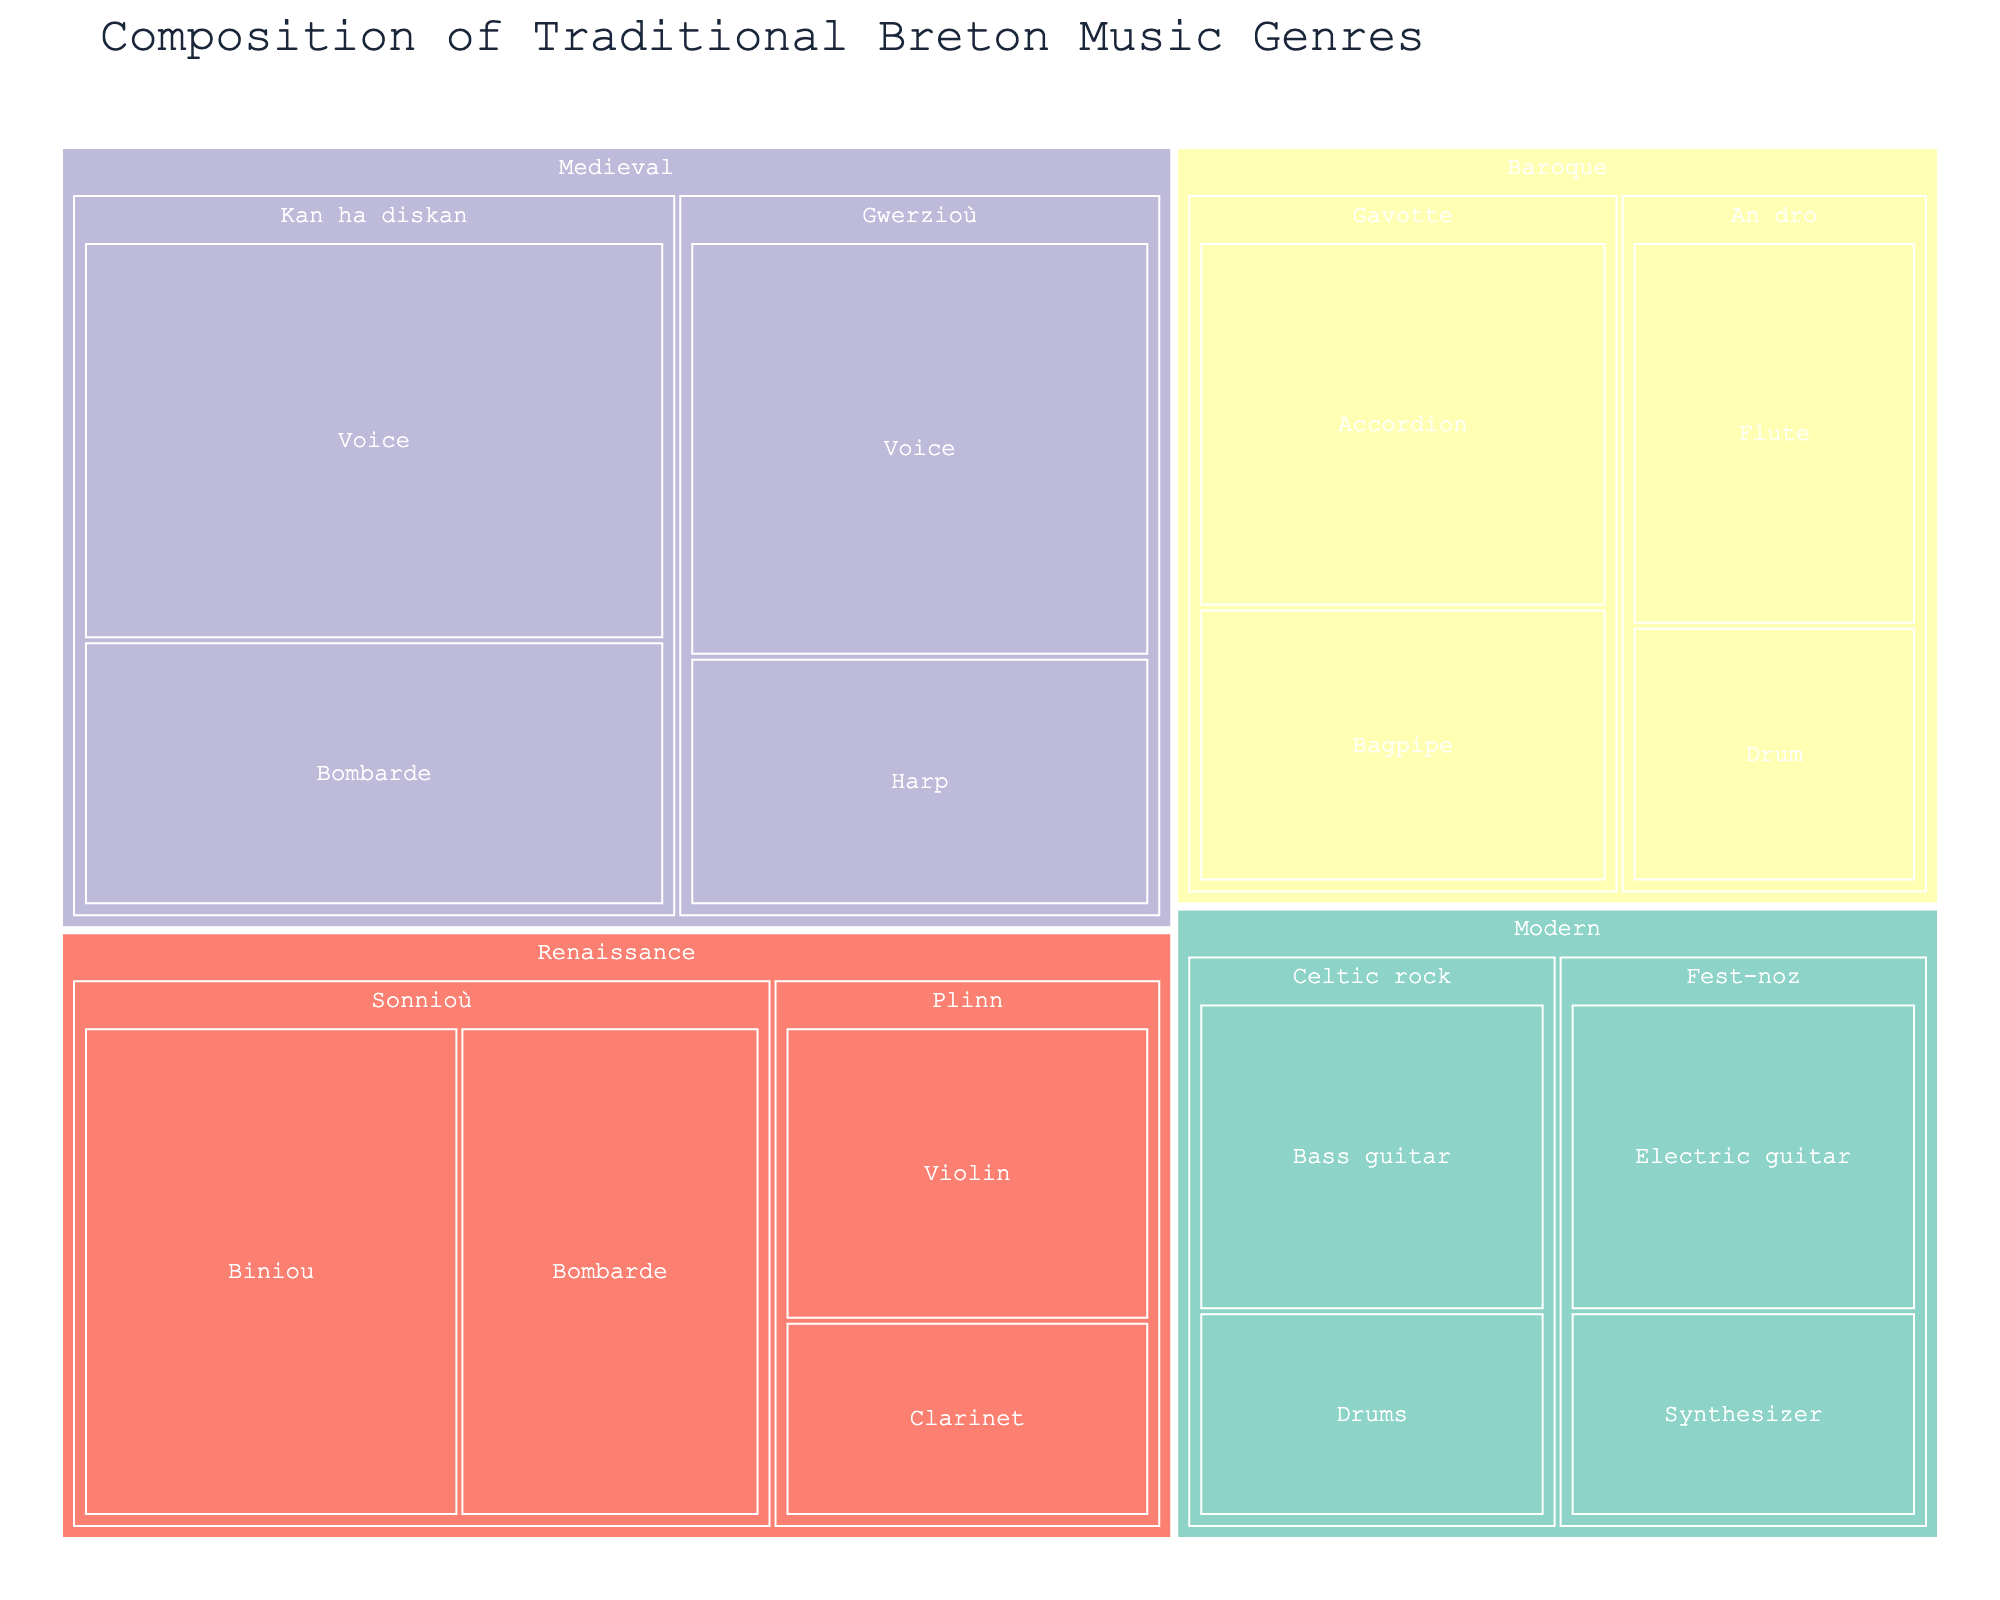What's the title of the plot? The title is located at the top center of the plot and is typically in larger font.
Answer: Composition of Traditional Breton Music Genres What period has the highest total value for its Subcategories? We need to sum the values of all Subcategories for each period. For Medieval: 30+20+25+15=90, Renaissance: 25+20+15+10=70, Baroque: 20+15+15+10=60, Modern: 15+10+15+10=50. The period with the highest total value is Medieval with 90.
Answer: Medieval Which subcategory in the Renaissance period has the highest value? Referring to the Renaissance Subcategories: Sonnioù (25 + 20 = 45) and Plinn (15 + 10 = 25). Sonnioù has the highest total value.
Answer: Sonnioù How many musical periods are represented in the figure? Count the unique top-level categories representing the periods (Medieval, Renaissance, Baroque, Modern).
Answer: Four Does Celtic rock in the Modern period use more or less instruments compared to An dro in the Baroque period? Celtic rock has Electric guitar (15) and Bass guitar (15) with a total of 15+10=25. An dro has Flute (15) and Drum (10) with a total of 15+10=25. Both use 25.
Answer: Equally Which instrument is most frequently used across all periods? Count the frequency of each instrument. Voice (2), Bombarde (2), Harp (1), Biniou (1), Violin (1), Clarinet (1), Accordion (1), Bagpipe (1), Flute (1), Drum (2), Electric guitar (1), Synthesizer (1), Bass guitar (1), Drums (1). Bombarde and Drum are most frequent, each appearing twice.
Answer: Bombarde, Drum 